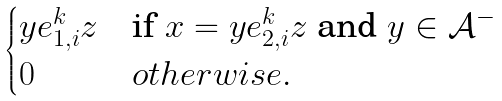<formula> <loc_0><loc_0><loc_500><loc_500>\begin{cases} y e _ { 1 , i } ^ { k } z & \text {if} \ x = y e _ { 2 , i } ^ { k } z \text { and } y \in \mathcal { A } ^ { - } \\ 0 & o t h e r w i s e . \end{cases}</formula> 